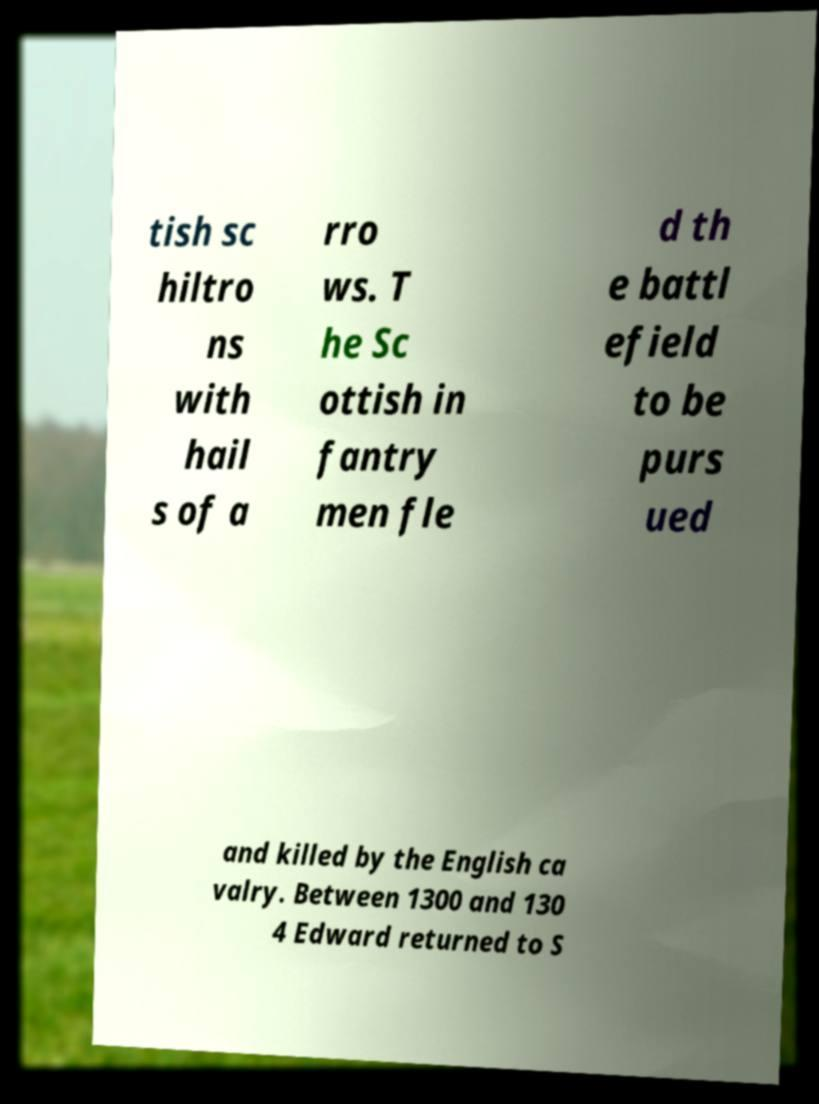Please identify and transcribe the text found in this image. tish sc hiltro ns with hail s of a rro ws. T he Sc ottish in fantry men fle d th e battl efield to be purs ued and killed by the English ca valry. Between 1300 and 130 4 Edward returned to S 